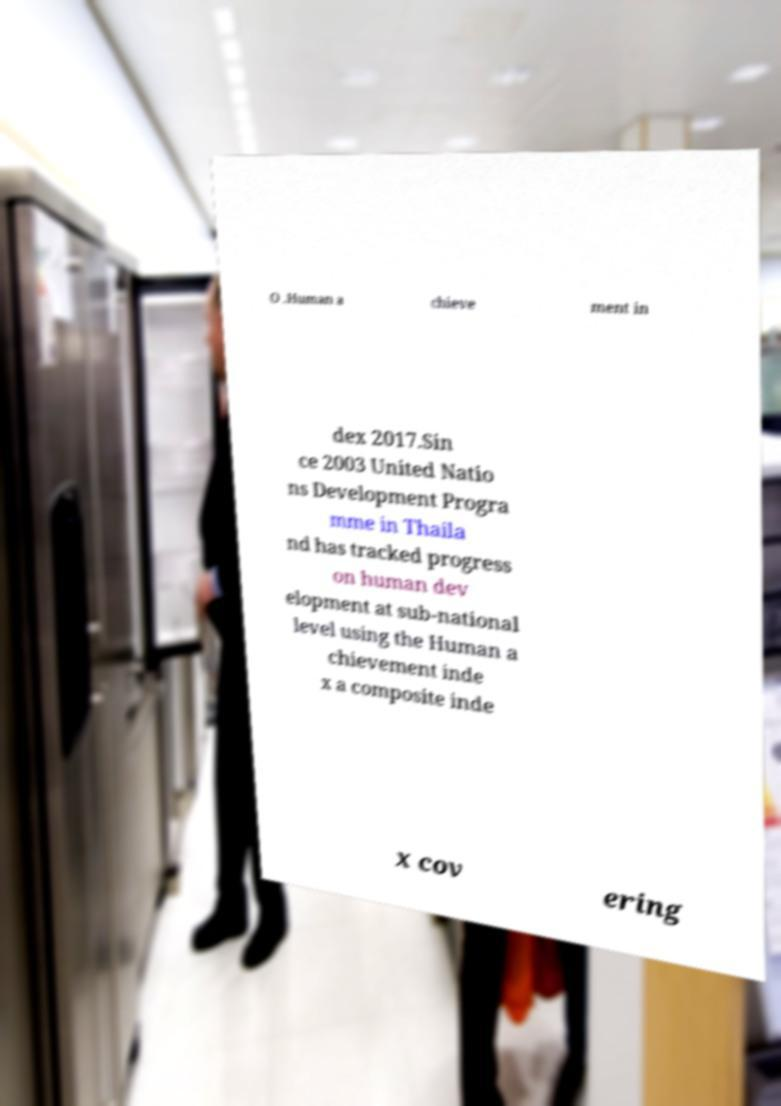Please identify and transcribe the text found in this image. O .Human a chieve ment in dex 2017.Sin ce 2003 United Natio ns Development Progra mme in Thaila nd has tracked progress on human dev elopment at sub-national level using the Human a chievement inde x a composite inde x cov ering 